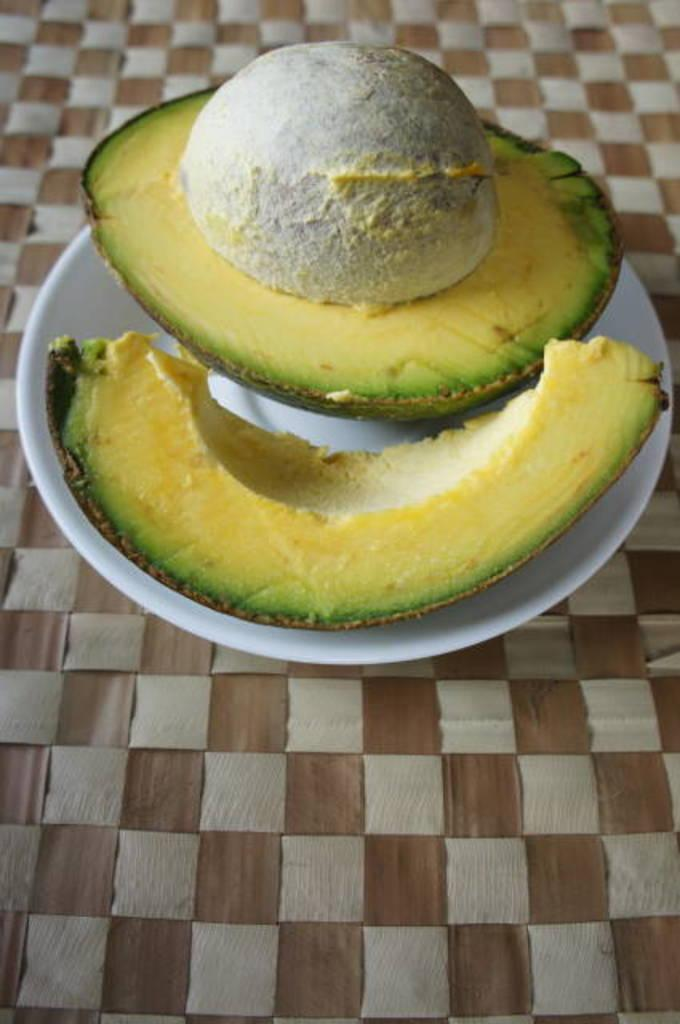What is on the plate that is visible in the image? There is food on a plate in the image. What is the color of the plate? The plate is white in color. Where is the rabbit hiding in the image? There is no rabbit present in the image. What type of paste is being used to create the curve on the plate? There is no paste or curve present on the plate in the image. 